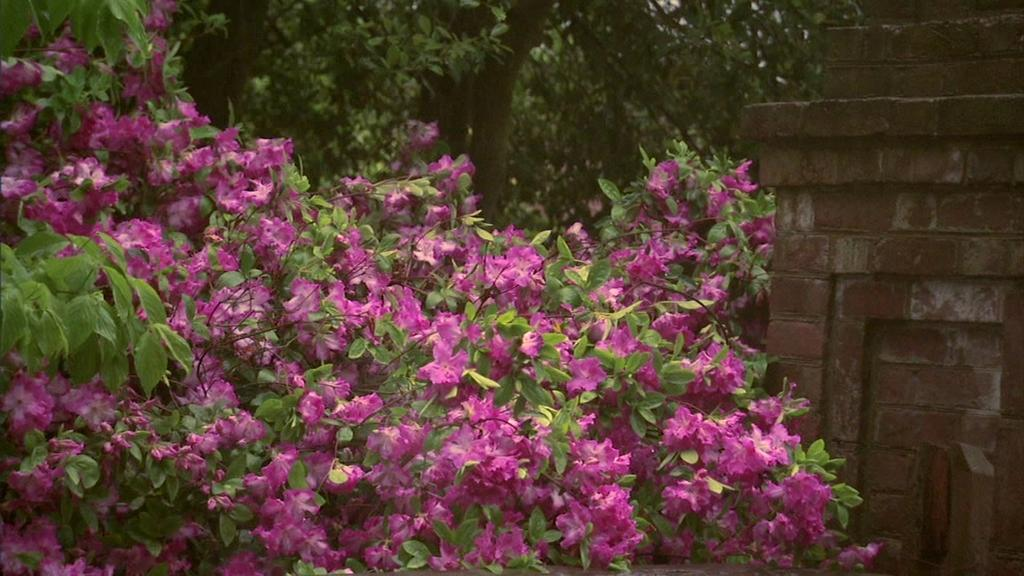What type of plants can be seen in the image? There are plants with flowers in the image. What other vegetation is present in the image? There are trees in the image. What structure can be seen in the background? There is a wall visible in the image. What type of jewel can be seen on the tree in the image? There are no jewels present on the trees in the image; only plants, flowers, and trees can be seen. 